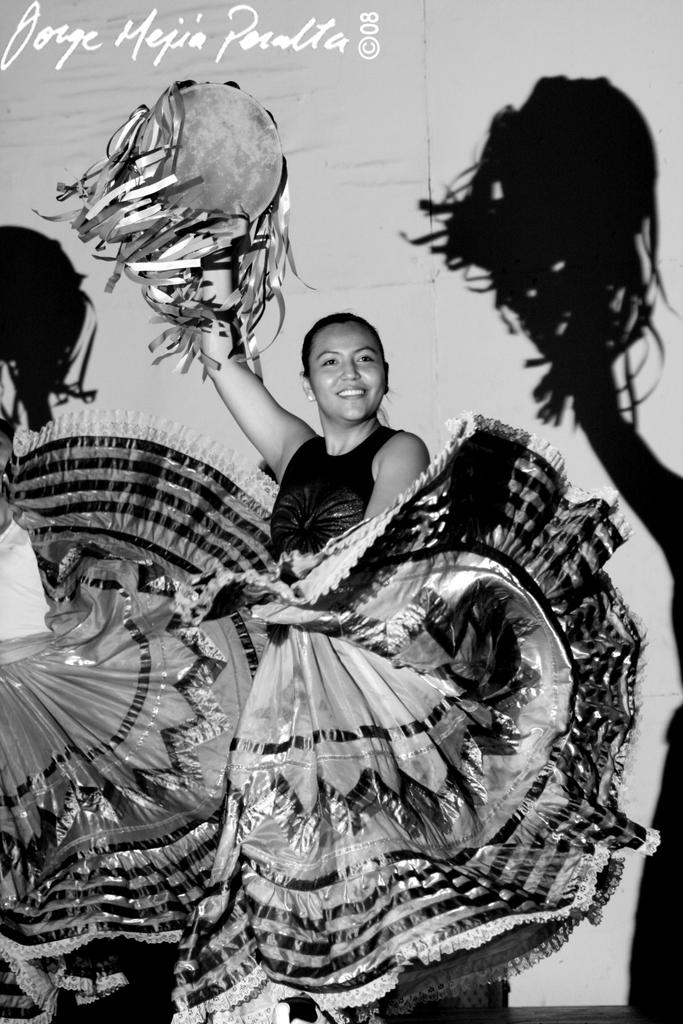What is the color scheme of the image? The image is black and white. Can you describe the main subject in the image? There is a person standing in the image. What can be observed about the person's attire? The person is wearing clothes. What is the person holding in their hand? The person is holding something with their hand. How much sugar is visible in the image? There is no sugar present in the image. What type of selection is being made by the person in the image? The image does not provide information about any selection being made by the person. 